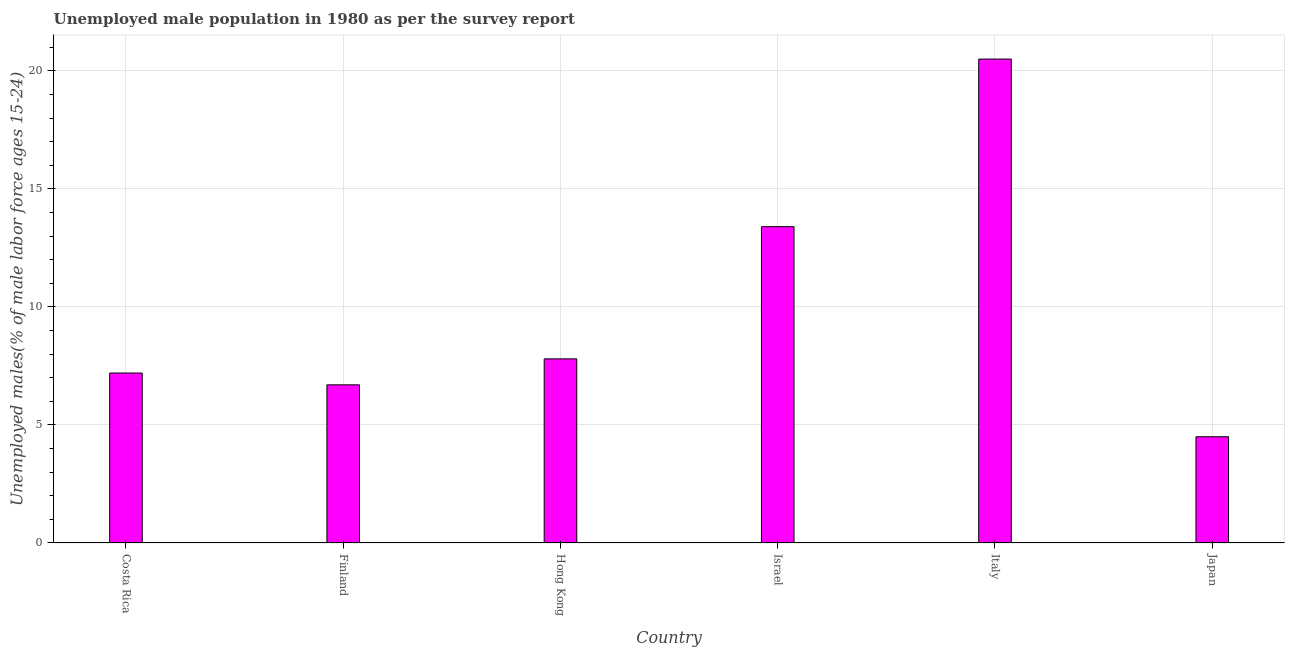What is the title of the graph?
Your response must be concise. Unemployed male population in 1980 as per the survey report. What is the label or title of the X-axis?
Give a very brief answer. Country. What is the label or title of the Y-axis?
Give a very brief answer. Unemployed males(% of male labor force ages 15-24). Across all countries, what is the maximum unemployed male youth?
Ensure brevity in your answer.  20.5. Across all countries, what is the minimum unemployed male youth?
Your response must be concise. 4.5. In which country was the unemployed male youth maximum?
Keep it short and to the point. Italy. In which country was the unemployed male youth minimum?
Provide a short and direct response. Japan. What is the sum of the unemployed male youth?
Your answer should be compact. 60.1. What is the average unemployed male youth per country?
Keep it short and to the point. 10.02. What is the median unemployed male youth?
Offer a very short reply. 7.5. In how many countries, is the unemployed male youth greater than 15 %?
Offer a terse response. 1. What is the ratio of the unemployed male youth in Hong Kong to that in Israel?
Keep it short and to the point. 0.58. Is the difference between the unemployed male youth in Finland and Hong Kong greater than the difference between any two countries?
Offer a very short reply. No. In how many countries, is the unemployed male youth greater than the average unemployed male youth taken over all countries?
Your answer should be compact. 2. Are all the bars in the graph horizontal?
Provide a succinct answer. No. How many countries are there in the graph?
Provide a succinct answer. 6. What is the difference between two consecutive major ticks on the Y-axis?
Ensure brevity in your answer.  5. Are the values on the major ticks of Y-axis written in scientific E-notation?
Provide a succinct answer. No. What is the Unemployed males(% of male labor force ages 15-24) of Costa Rica?
Ensure brevity in your answer.  7.2. What is the Unemployed males(% of male labor force ages 15-24) in Finland?
Your answer should be compact. 6.7. What is the Unemployed males(% of male labor force ages 15-24) in Hong Kong?
Offer a terse response. 7.8. What is the Unemployed males(% of male labor force ages 15-24) of Israel?
Keep it short and to the point. 13.4. What is the Unemployed males(% of male labor force ages 15-24) in Japan?
Ensure brevity in your answer.  4.5. What is the difference between the Unemployed males(% of male labor force ages 15-24) in Finland and Israel?
Provide a succinct answer. -6.7. What is the difference between the Unemployed males(% of male labor force ages 15-24) in Finland and Japan?
Offer a very short reply. 2.2. What is the difference between the Unemployed males(% of male labor force ages 15-24) in Hong Kong and Israel?
Provide a short and direct response. -5.6. What is the difference between the Unemployed males(% of male labor force ages 15-24) in Israel and Japan?
Offer a very short reply. 8.9. What is the difference between the Unemployed males(% of male labor force ages 15-24) in Italy and Japan?
Your response must be concise. 16. What is the ratio of the Unemployed males(% of male labor force ages 15-24) in Costa Rica to that in Finland?
Offer a terse response. 1.07. What is the ratio of the Unemployed males(% of male labor force ages 15-24) in Costa Rica to that in Hong Kong?
Offer a very short reply. 0.92. What is the ratio of the Unemployed males(% of male labor force ages 15-24) in Costa Rica to that in Israel?
Make the answer very short. 0.54. What is the ratio of the Unemployed males(% of male labor force ages 15-24) in Costa Rica to that in Italy?
Your response must be concise. 0.35. What is the ratio of the Unemployed males(% of male labor force ages 15-24) in Finland to that in Hong Kong?
Offer a very short reply. 0.86. What is the ratio of the Unemployed males(% of male labor force ages 15-24) in Finland to that in Italy?
Offer a very short reply. 0.33. What is the ratio of the Unemployed males(% of male labor force ages 15-24) in Finland to that in Japan?
Your response must be concise. 1.49. What is the ratio of the Unemployed males(% of male labor force ages 15-24) in Hong Kong to that in Israel?
Keep it short and to the point. 0.58. What is the ratio of the Unemployed males(% of male labor force ages 15-24) in Hong Kong to that in Italy?
Ensure brevity in your answer.  0.38. What is the ratio of the Unemployed males(% of male labor force ages 15-24) in Hong Kong to that in Japan?
Provide a succinct answer. 1.73. What is the ratio of the Unemployed males(% of male labor force ages 15-24) in Israel to that in Italy?
Keep it short and to the point. 0.65. What is the ratio of the Unemployed males(% of male labor force ages 15-24) in Israel to that in Japan?
Your answer should be compact. 2.98. What is the ratio of the Unemployed males(% of male labor force ages 15-24) in Italy to that in Japan?
Give a very brief answer. 4.56. 